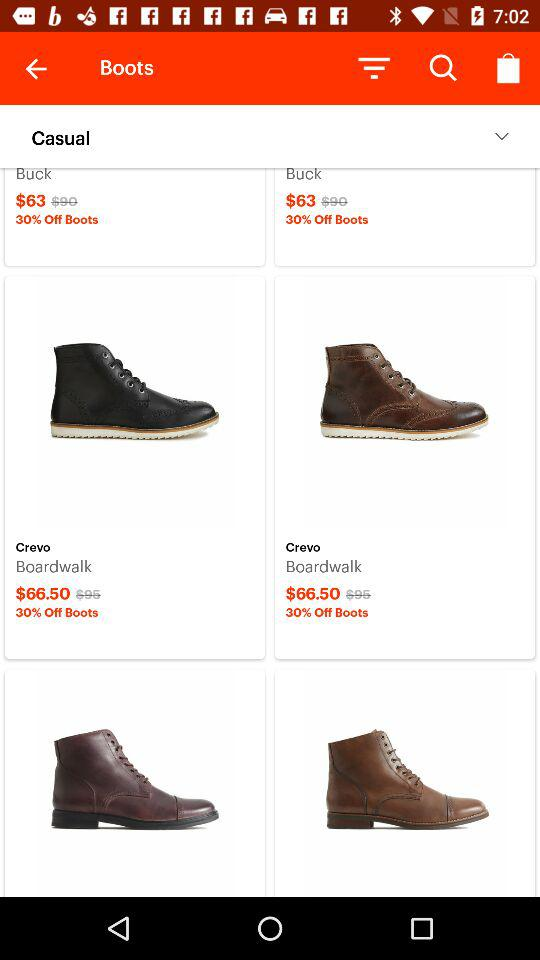What is the price of a boardwalk? The price is $66.50. 